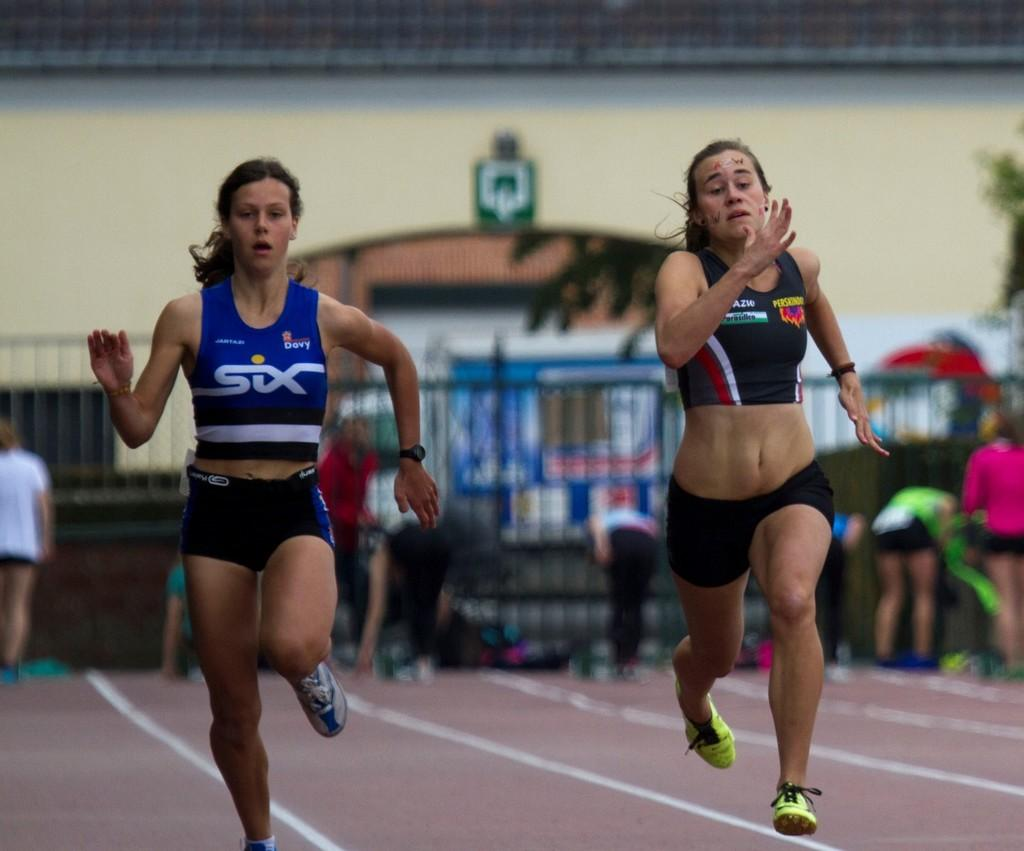<image>
Relay a brief, clear account of the picture shown. Two runners are racing on a track, the one on the left wearing a Six top. 